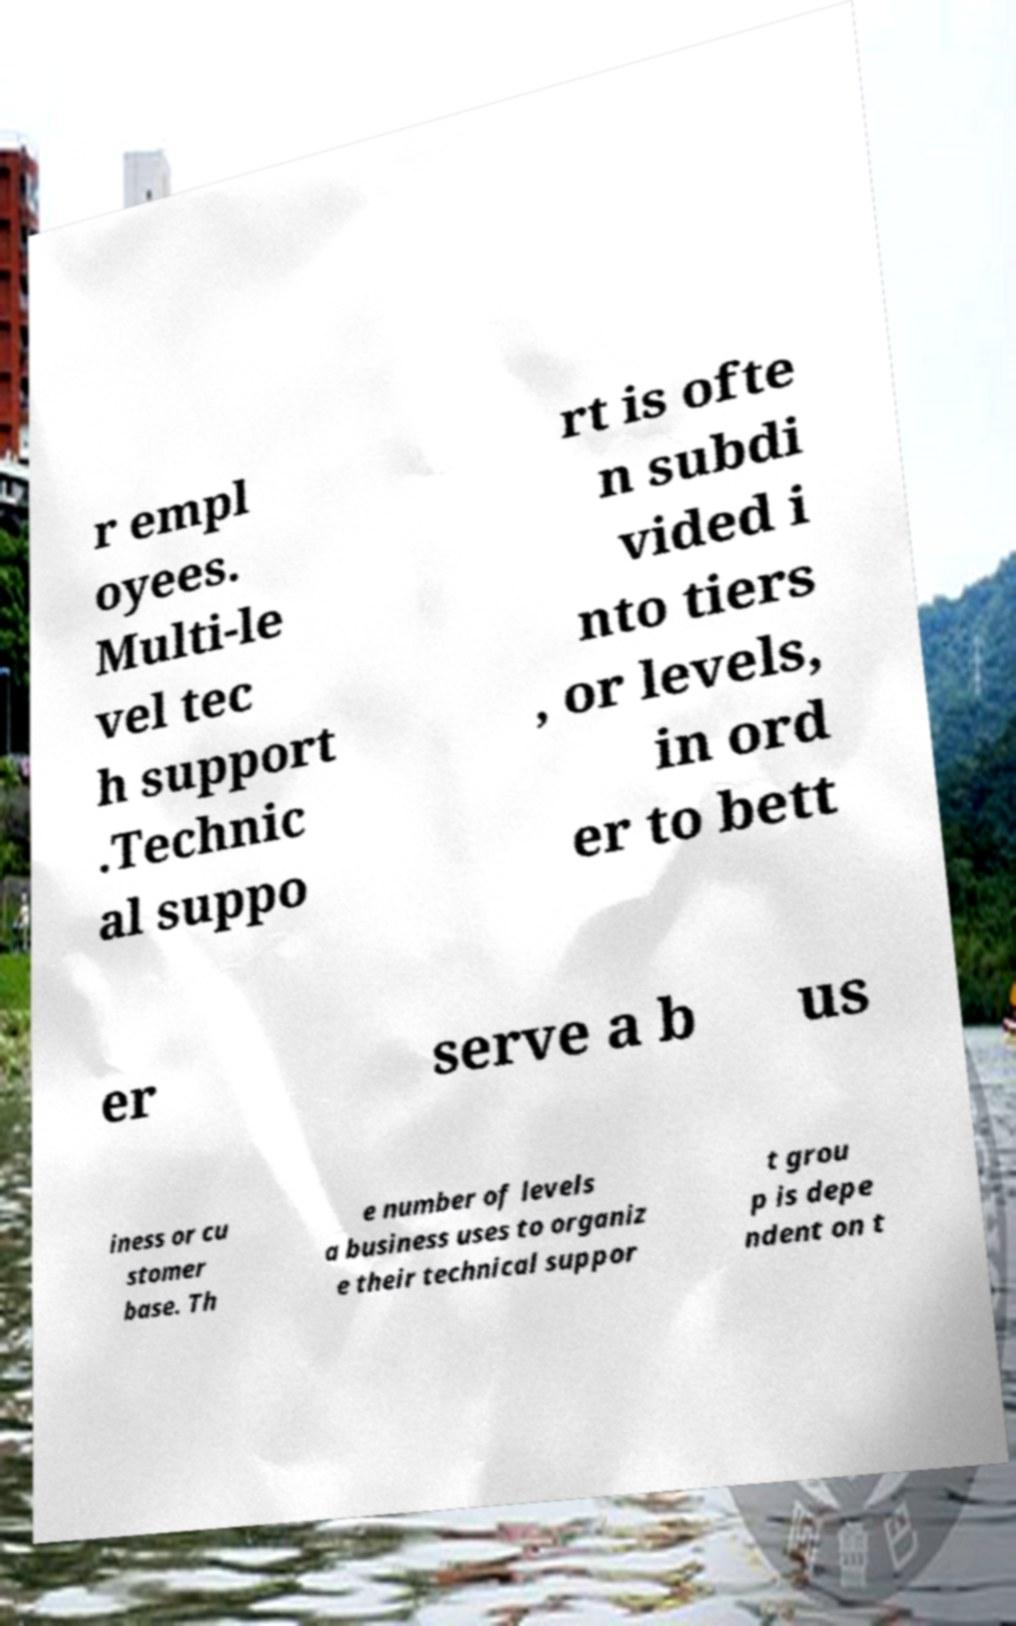Please read and relay the text visible in this image. What does it say? r empl oyees. Multi-le vel tec h support .Technic al suppo rt is ofte n subdi vided i nto tiers , or levels, in ord er to bett er serve a b us iness or cu stomer base. Th e number of levels a business uses to organiz e their technical suppor t grou p is depe ndent on t 